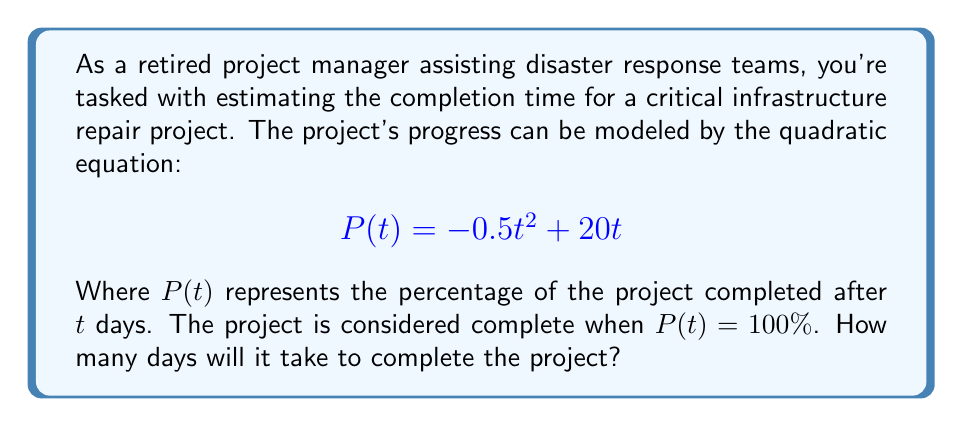What is the answer to this math problem? To solve this problem, we need to follow these steps:

1) We're looking for the time $t$ when $P(t) = 100\%$. So, we need to solve the equation:

   $$100 = -0.5t^2 + 20t$$

2) Rearrange the equation to standard form:

   $$0.5t^2 - 20t + 100 = 0$$

3) This is a quadratic equation in the form $ax^2 + bx + c = 0$, where:
   $a = 0.5$, $b = -20$, and $c = 100$

4) We can solve this using the quadratic formula: $x = \frac{-b \pm \sqrt{b^2 - 4ac}}{2a}$

5) Plugging in our values:

   $$t = \frac{20 \pm \sqrt{(-20)^2 - 4(0.5)(100)}}{2(0.5)}$$

6) Simplify:

   $$t = \frac{20 \pm \sqrt{400 - 200}}{1} = \frac{20 \pm \sqrt{200}}{1} = 20 \pm \sqrt{200}$$

7) Simplify further:

   $$t = 20 \pm 10\sqrt{2}$$

8) This gives us two solutions:

   $$t_1 = 20 + 10\sqrt{2} \approx 34.14$$
   $$t_2 = 20 - 10\sqrt{2} \approx 5.86$$

9) Since we're asking how long it will take to complete the project, we need the positive solution that's greater than zero. Therefore, we choose $t_1$.
Answer: It will take approximately 34.14 days to complete the project. 